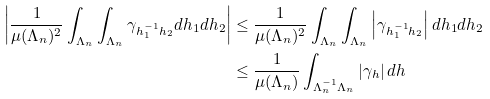<formula> <loc_0><loc_0><loc_500><loc_500>\left | \frac { 1 } { \mu ( \Lambda _ { n } ) ^ { 2 } } \int _ { \Lambda _ { n } } \int _ { \Lambda _ { n } } \gamma _ { h _ { 1 } ^ { - 1 } h _ { 2 } } d h _ { 1 } d h _ { 2 } \right | & \leq \frac { 1 } { \mu ( \Lambda _ { n } ) ^ { 2 } } \int _ { \Lambda _ { n } } \int _ { \Lambda _ { n } } \left | \gamma _ { h _ { 1 } ^ { - 1 } h _ { 2 } } \right | d h _ { 1 } d h _ { 2 } \\ & \leq \frac { 1 } { \mu ( \Lambda _ { n } ) } \int _ { \Lambda _ { n } ^ { - 1 } \Lambda _ { n } } \left | \gamma _ { h } \right | d h</formula> 